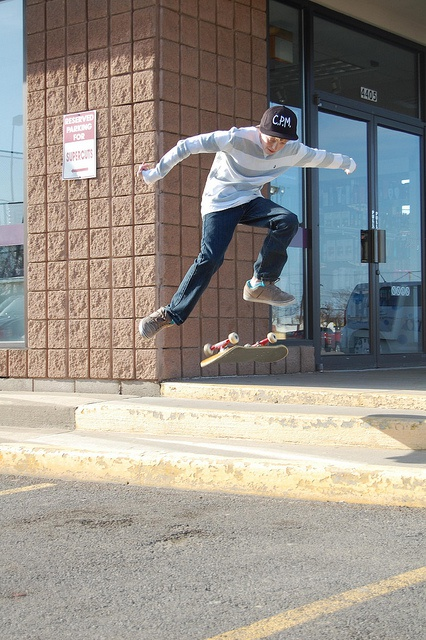Describe the objects in this image and their specific colors. I can see people in black, darkgray, gray, and white tones and skateboard in black, gray, ivory, and darkgray tones in this image. 